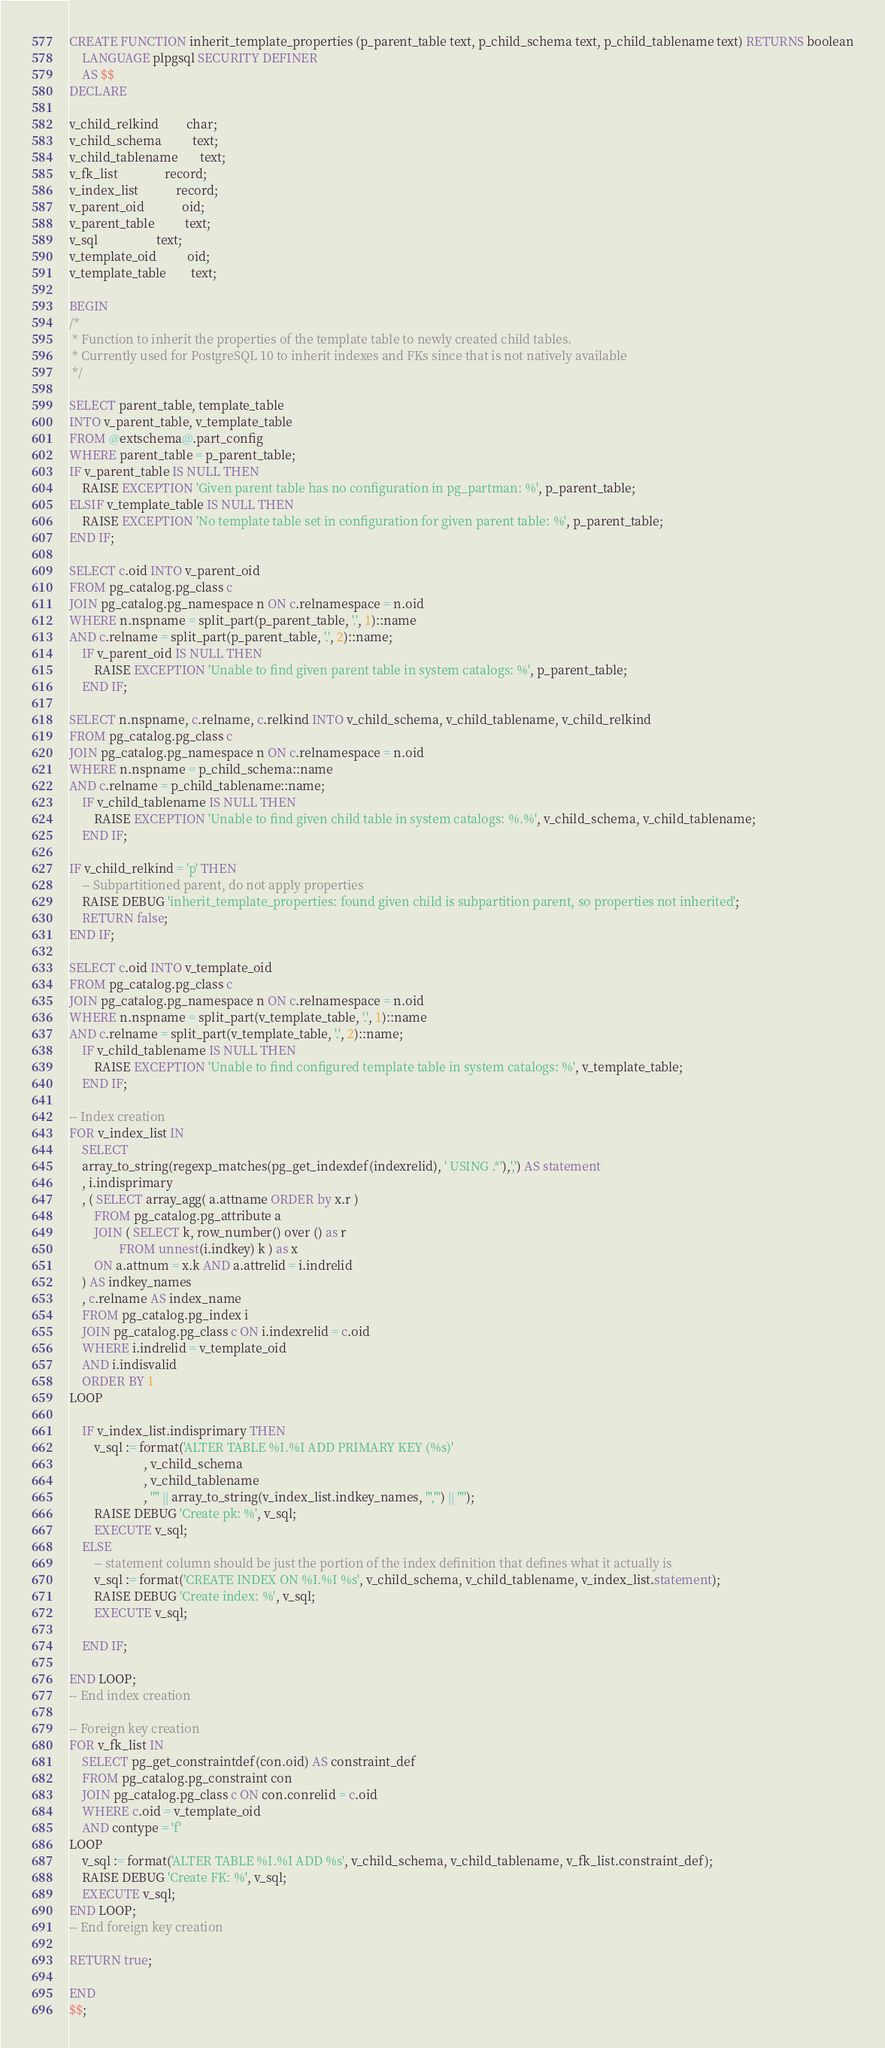<code> <loc_0><loc_0><loc_500><loc_500><_SQL_>CREATE FUNCTION inherit_template_properties (p_parent_table text, p_child_schema text, p_child_tablename text) RETURNS boolean
    LANGUAGE plpgsql SECURITY DEFINER
    AS $$
DECLARE

v_child_relkind         char;
v_child_schema          text;
v_child_tablename       text;
v_fk_list               record;
v_index_list            record;
v_parent_oid            oid;
v_parent_table          text;
v_sql                   text;
v_template_oid          oid;
v_template_table        text;

BEGIN
/*
 * Function to inherit the properties of the template table to newly created child tables.
 * Currently used for PostgreSQL 10 to inherit indexes and FKs since that is not natively available
 */

SELECT parent_table, template_table
INTO v_parent_table, v_template_table
FROM @extschema@.part_config
WHERE parent_table = p_parent_table;
IF v_parent_table IS NULL THEN
    RAISE EXCEPTION 'Given parent table has no configuration in pg_partman: %', p_parent_table;
ELSIF v_template_table IS NULL THEN
    RAISE EXCEPTION 'No template table set in configuration for given parent table: %', p_parent_table;
END IF;
 
SELECT c.oid INTO v_parent_oid
FROM pg_catalog.pg_class c
JOIN pg_catalog.pg_namespace n ON c.relnamespace = n.oid
WHERE n.nspname = split_part(p_parent_table, '.', 1)::name
AND c.relname = split_part(p_parent_table, '.', 2)::name;
    IF v_parent_oid IS NULL THEN
        RAISE EXCEPTION 'Unable to find given parent table in system catalogs: %', p_parent_table;
    END IF;
 
SELECT n.nspname, c.relname, c.relkind INTO v_child_schema, v_child_tablename, v_child_relkind
FROM pg_catalog.pg_class c
JOIN pg_catalog.pg_namespace n ON c.relnamespace = n.oid
WHERE n.nspname = p_child_schema::name
AND c.relname = p_child_tablename::name;
    IF v_child_tablename IS NULL THEN
        RAISE EXCEPTION 'Unable to find given child table in system catalogs: %.%', v_child_schema, v_child_tablename;
    END IF;
       
IF v_child_relkind = 'p' THEN
    -- Subpartitioned parent, do not apply properties
    RAISE DEBUG 'inherit_template_properties: found given child is subpartition parent, so properties not inherited';
    RETURN false;
END IF;

SELECT c.oid INTO v_template_oid
FROM pg_catalog.pg_class c
JOIN pg_catalog.pg_namespace n ON c.relnamespace = n.oid
WHERE n.nspname = split_part(v_template_table, '.', 1)::name
AND c.relname = split_part(v_template_table, '.', 2)::name;
    IF v_child_tablename IS NULL THEN
        RAISE EXCEPTION 'Unable to find configured template table in system catalogs: %', v_template_table;
    END IF;

-- Index creation
FOR v_index_list IN 
    SELECT
    array_to_string(regexp_matches(pg_get_indexdef(indexrelid), ' USING .*'),',') AS statement
    , i.indisprimary
    , ( SELECT array_agg( a.attname ORDER by x.r )
        FROM pg_catalog.pg_attribute a
        JOIN ( SELECT k, row_number() over () as r
                FROM unnest(i.indkey) k ) as x
        ON a.attnum = x.k AND a.attrelid = i.indrelid
    ) AS indkey_names
    , c.relname AS index_name
    FROM pg_catalog.pg_index i
    JOIN pg_catalog.pg_class c ON i.indexrelid = c.oid
    WHERE i.indrelid = v_template_oid
    AND i.indisvalid
    ORDER BY 1
LOOP

    IF v_index_list.indisprimary THEN
        v_sql := format('ALTER TABLE %I.%I ADD PRIMARY KEY (%s)'
                        , v_child_schema
                        , v_child_tablename
                        , '"' || array_to_string(v_index_list.indkey_names, '","') || '"');
        RAISE DEBUG 'Create pk: %', v_sql;
        EXECUTE v_sql;
    ELSE
        -- statement column should be just the portion of the index definition that defines what it actually is
        v_sql := format('CREATE INDEX ON %I.%I %s', v_child_schema, v_child_tablename, v_index_list.statement);
        RAISE DEBUG 'Create index: %', v_sql;
        EXECUTE v_sql;

    END IF;

END LOOP;
-- End index creation

-- Foreign key creation
FOR v_fk_list IN 
    SELECT pg_get_constraintdef(con.oid) AS constraint_def
    FROM pg_catalog.pg_constraint con
    JOIN pg_catalog.pg_class c ON con.conrelid = c.oid
    WHERE c.oid = v_template_oid
    AND contype = 'f'
LOOP
    v_sql := format('ALTER TABLE %I.%I ADD %s', v_child_schema, v_child_tablename, v_fk_list.constraint_def);
    RAISE DEBUG 'Create FK: %', v_sql;
    EXECUTE v_sql;
END LOOP;
-- End foreign key creation

RETURN true;

END
$$;


</code> 